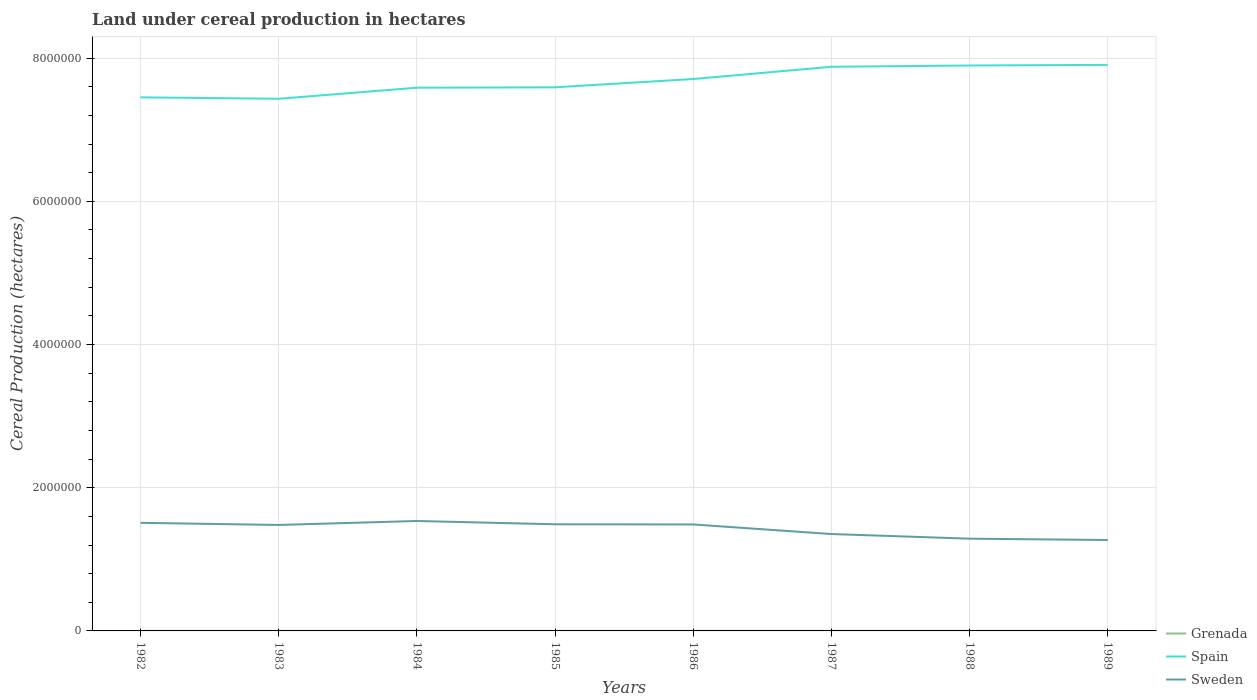Is the number of lines equal to the number of legend labels?
Ensure brevity in your answer.  Yes. Across all years, what is the maximum land under cereal production in Sweden?
Keep it short and to the point. 1.27e+06. What is the total land under cereal production in Sweden in the graph?
Make the answer very short. 8.33e+04. What is the difference between the highest and the second highest land under cereal production in Grenada?
Provide a short and direct response. 220. What is the difference between the highest and the lowest land under cereal production in Sweden?
Give a very brief answer. 5. Is the land under cereal production in Sweden strictly greater than the land under cereal production in Spain over the years?
Provide a succinct answer. Yes. How many lines are there?
Your response must be concise. 3. How many years are there in the graph?
Your answer should be very brief. 8. Are the values on the major ticks of Y-axis written in scientific E-notation?
Keep it short and to the point. No. Does the graph contain any zero values?
Your response must be concise. No. What is the title of the graph?
Offer a terse response. Land under cereal production in hectares. What is the label or title of the X-axis?
Provide a succinct answer. Years. What is the label or title of the Y-axis?
Offer a terse response. Cereal Production (hectares). What is the Cereal Production (hectares) of Grenada in 1982?
Provide a short and direct response. 470. What is the Cereal Production (hectares) of Spain in 1982?
Offer a very short reply. 7.45e+06. What is the Cereal Production (hectares) in Sweden in 1982?
Make the answer very short. 1.51e+06. What is the Cereal Production (hectares) in Grenada in 1983?
Provide a short and direct response. 414. What is the Cereal Production (hectares) in Spain in 1983?
Ensure brevity in your answer.  7.43e+06. What is the Cereal Production (hectares) of Sweden in 1983?
Make the answer very short. 1.48e+06. What is the Cereal Production (hectares) in Grenada in 1984?
Provide a succinct answer. 414. What is the Cereal Production (hectares) in Spain in 1984?
Provide a short and direct response. 7.59e+06. What is the Cereal Production (hectares) of Sweden in 1984?
Make the answer very short. 1.54e+06. What is the Cereal Production (hectares) in Grenada in 1985?
Your response must be concise. 410. What is the Cereal Production (hectares) in Spain in 1985?
Offer a very short reply. 7.59e+06. What is the Cereal Production (hectares) of Sweden in 1985?
Your answer should be very brief. 1.49e+06. What is the Cereal Production (hectares) in Grenada in 1986?
Provide a succinct answer. 250. What is the Cereal Production (hectares) in Spain in 1986?
Offer a terse response. 7.71e+06. What is the Cereal Production (hectares) in Sweden in 1986?
Offer a very short reply. 1.49e+06. What is the Cereal Production (hectares) in Grenada in 1987?
Your response must be concise. 250. What is the Cereal Production (hectares) of Spain in 1987?
Give a very brief answer. 7.88e+06. What is the Cereal Production (hectares) in Sweden in 1987?
Make the answer very short. 1.35e+06. What is the Cereal Production (hectares) of Grenada in 1988?
Offer a very short reply. 250. What is the Cereal Production (hectares) in Spain in 1988?
Make the answer very short. 7.90e+06. What is the Cereal Production (hectares) in Sweden in 1988?
Make the answer very short. 1.29e+06. What is the Cereal Production (hectares) of Grenada in 1989?
Your response must be concise. 255. What is the Cereal Production (hectares) in Spain in 1989?
Your response must be concise. 7.91e+06. What is the Cereal Production (hectares) of Sweden in 1989?
Your response must be concise. 1.27e+06. Across all years, what is the maximum Cereal Production (hectares) of Grenada?
Your answer should be compact. 470. Across all years, what is the maximum Cereal Production (hectares) in Spain?
Offer a very short reply. 7.91e+06. Across all years, what is the maximum Cereal Production (hectares) in Sweden?
Offer a terse response. 1.54e+06. Across all years, what is the minimum Cereal Production (hectares) of Grenada?
Your answer should be very brief. 250. Across all years, what is the minimum Cereal Production (hectares) in Spain?
Keep it short and to the point. 7.43e+06. Across all years, what is the minimum Cereal Production (hectares) of Sweden?
Ensure brevity in your answer.  1.27e+06. What is the total Cereal Production (hectares) in Grenada in the graph?
Offer a terse response. 2713. What is the total Cereal Production (hectares) of Spain in the graph?
Offer a terse response. 6.15e+07. What is the total Cereal Production (hectares) in Sweden in the graph?
Provide a succinct answer. 1.14e+07. What is the difference between the Cereal Production (hectares) in Spain in 1982 and that in 1983?
Offer a terse response. 1.99e+04. What is the difference between the Cereal Production (hectares) in Sweden in 1982 and that in 1983?
Provide a succinct answer. 2.98e+04. What is the difference between the Cereal Production (hectares) of Spain in 1982 and that in 1984?
Offer a terse response. -1.35e+05. What is the difference between the Cereal Production (hectares) in Sweden in 1982 and that in 1984?
Your response must be concise. -2.56e+04. What is the difference between the Cereal Production (hectares) of Spain in 1982 and that in 1985?
Give a very brief answer. -1.40e+05. What is the difference between the Cereal Production (hectares) in Sweden in 1982 and that in 1985?
Provide a short and direct response. 2.03e+04. What is the difference between the Cereal Production (hectares) in Grenada in 1982 and that in 1986?
Ensure brevity in your answer.  220. What is the difference between the Cereal Production (hectares) of Spain in 1982 and that in 1986?
Your response must be concise. -2.56e+05. What is the difference between the Cereal Production (hectares) of Sweden in 1982 and that in 1986?
Provide a succinct answer. 2.28e+04. What is the difference between the Cereal Production (hectares) in Grenada in 1982 and that in 1987?
Make the answer very short. 220. What is the difference between the Cereal Production (hectares) of Spain in 1982 and that in 1987?
Ensure brevity in your answer.  -4.27e+05. What is the difference between the Cereal Production (hectares) in Sweden in 1982 and that in 1987?
Provide a short and direct response. 1.57e+05. What is the difference between the Cereal Production (hectares) of Grenada in 1982 and that in 1988?
Provide a succinct answer. 220. What is the difference between the Cereal Production (hectares) of Spain in 1982 and that in 1988?
Ensure brevity in your answer.  -4.45e+05. What is the difference between the Cereal Production (hectares) in Sweden in 1982 and that in 1988?
Your answer should be very brief. 2.21e+05. What is the difference between the Cereal Production (hectares) in Grenada in 1982 and that in 1989?
Your answer should be very brief. 215. What is the difference between the Cereal Production (hectares) in Spain in 1982 and that in 1989?
Give a very brief answer. -4.53e+05. What is the difference between the Cereal Production (hectares) of Sweden in 1982 and that in 1989?
Offer a terse response. 2.40e+05. What is the difference between the Cereal Production (hectares) in Spain in 1983 and that in 1984?
Your answer should be very brief. -1.55e+05. What is the difference between the Cereal Production (hectares) in Sweden in 1983 and that in 1984?
Provide a succinct answer. -5.54e+04. What is the difference between the Cereal Production (hectares) of Spain in 1983 and that in 1985?
Offer a terse response. -1.60e+05. What is the difference between the Cereal Production (hectares) in Sweden in 1983 and that in 1985?
Ensure brevity in your answer.  -9501. What is the difference between the Cereal Production (hectares) of Grenada in 1983 and that in 1986?
Make the answer very short. 164. What is the difference between the Cereal Production (hectares) in Spain in 1983 and that in 1986?
Your answer should be very brief. -2.76e+05. What is the difference between the Cereal Production (hectares) of Sweden in 1983 and that in 1986?
Ensure brevity in your answer.  -7001. What is the difference between the Cereal Production (hectares) of Grenada in 1983 and that in 1987?
Give a very brief answer. 164. What is the difference between the Cereal Production (hectares) of Spain in 1983 and that in 1987?
Provide a succinct answer. -4.47e+05. What is the difference between the Cereal Production (hectares) in Sweden in 1983 and that in 1987?
Keep it short and to the point. 1.27e+05. What is the difference between the Cereal Production (hectares) in Grenada in 1983 and that in 1988?
Keep it short and to the point. 164. What is the difference between the Cereal Production (hectares) of Spain in 1983 and that in 1988?
Ensure brevity in your answer.  -4.65e+05. What is the difference between the Cereal Production (hectares) of Sweden in 1983 and that in 1988?
Ensure brevity in your answer.  1.92e+05. What is the difference between the Cereal Production (hectares) of Grenada in 1983 and that in 1989?
Keep it short and to the point. 159. What is the difference between the Cereal Production (hectares) of Spain in 1983 and that in 1989?
Offer a very short reply. -4.73e+05. What is the difference between the Cereal Production (hectares) in Sweden in 1983 and that in 1989?
Make the answer very short. 2.10e+05. What is the difference between the Cereal Production (hectares) of Grenada in 1984 and that in 1985?
Ensure brevity in your answer.  4. What is the difference between the Cereal Production (hectares) of Spain in 1984 and that in 1985?
Your response must be concise. -5503. What is the difference between the Cereal Production (hectares) in Sweden in 1984 and that in 1985?
Provide a succinct answer. 4.59e+04. What is the difference between the Cereal Production (hectares) in Grenada in 1984 and that in 1986?
Provide a succinct answer. 164. What is the difference between the Cereal Production (hectares) of Spain in 1984 and that in 1986?
Your response must be concise. -1.21e+05. What is the difference between the Cereal Production (hectares) in Sweden in 1984 and that in 1986?
Your answer should be very brief. 4.84e+04. What is the difference between the Cereal Production (hectares) in Grenada in 1984 and that in 1987?
Make the answer very short. 164. What is the difference between the Cereal Production (hectares) in Spain in 1984 and that in 1987?
Offer a terse response. -2.92e+05. What is the difference between the Cereal Production (hectares) of Sweden in 1984 and that in 1987?
Your answer should be very brief. 1.82e+05. What is the difference between the Cereal Production (hectares) of Grenada in 1984 and that in 1988?
Provide a succinct answer. 164. What is the difference between the Cereal Production (hectares) in Spain in 1984 and that in 1988?
Provide a short and direct response. -3.10e+05. What is the difference between the Cereal Production (hectares) in Sweden in 1984 and that in 1988?
Offer a very short reply. 2.47e+05. What is the difference between the Cereal Production (hectares) in Grenada in 1984 and that in 1989?
Keep it short and to the point. 159. What is the difference between the Cereal Production (hectares) in Spain in 1984 and that in 1989?
Ensure brevity in your answer.  -3.19e+05. What is the difference between the Cereal Production (hectares) of Sweden in 1984 and that in 1989?
Give a very brief answer. 2.65e+05. What is the difference between the Cereal Production (hectares) in Grenada in 1985 and that in 1986?
Keep it short and to the point. 160. What is the difference between the Cereal Production (hectares) of Spain in 1985 and that in 1986?
Your response must be concise. -1.16e+05. What is the difference between the Cereal Production (hectares) of Sweden in 1985 and that in 1986?
Offer a very short reply. 2500. What is the difference between the Cereal Production (hectares) in Grenada in 1985 and that in 1987?
Offer a very short reply. 160. What is the difference between the Cereal Production (hectares) in Spain in 1985 and that in 1987?
Your response must be concise. -2.87e+05. What is the difference between the Cereal Production (hectares) of Sweden in 1985 and that in 1987?
Your answer should be very brief. 1.36e+05. What is the difference between the Cereal Production (hectares) of Grenada in 1985 and that in 1988?
Keep it short and to the point. 160. What is the difference between the Cereal Production (hectares) of Spain in 1985 and that in 1988?
Ensure brevity in your answer.  -3.05e+05. What is the difference between the Cereal Production (hectares) in Sweden in 1985 and that in 1988?
Provide a short and direct response. 2.01e+05. What is the difference between the Cereal Production (hectares) in Grenada in 1985 and that in 1989?
Make the answer very short. 155. What is the difference between the Cereal Production (hectares) in Spain in 1985 and that in 1989?
Make the answer very short. -3.13e+05. What is the difference between the Cereal Production (hectares) in Sweden in 1985 and that in 1989?
Offer a terse response. 2.20e+05. What is the difference between the Cereal Production (hectares) in Grenada in 1986 and that in 1987?
Give a very brief answer. 0. What is the difference between the Cereal Production (hectares) of Spain in 1986 and that in 1987?
Your response must be concise. -1.71e+05. What is the difference between the Cereal Production (hectares) of Sweden in 1986 and that in 1987?
Ensure brevity in your answer.  1.34e+05. What is the difference between the Cereal Production (hectares) in Grenada in 1986 and that in 1988?
Offer a terse response. 0. What is the difference between the Cereal Production (hectares) in Spain in 1986 and that in 1988?
Keep it short and to the point. -1.89e+05. What is the difference between the Cereal Production (hectares) of Sweden in 1986 and that in 1988?
Provide a succinct answer. 1.99e+05. What is the difference between the Cereal Production (hectares) of Spain in 1986 and that in 1989?
Your answer should be compact. -1.98e+05. What is the difference between the Cereal Production (hectares) in Sweden in 1986 and that in 1989?
Give a very brief answer. 2.17e+05. What is the difference between the Cereal Production (hectares) in Spain in 1987 and that in 1988?
Make the answer very short. -1.81e+04. What is the difference between the Cereal Production (hectares) of Sweden in 1987 and that in 1988?
Keep it short and to the point. 6.49e+04. What is the difference between the Cereal Production (hectares) in Spain in 1987 and that in 1989?
Make the answer very short. -2.66e+04. What is the difference between the Cereal Production (hectares) of Sweden in 1987 and that in 1989?
Provide a succinct answer. 8.33e+04. What is the difference between the Cereal Production (hectares) in Spain in 1988 and that in 1989?
Offer a terse response. -8497. What is the difference between the Cereal Production (hectares) in Sweden in 1988 and that in 1989?
Make the answer very short. 1.85e+04. What is the difference between the Cereal Production (hectares) of Grenada in 1982 and the Cereal Production (hectares) of Spain in 1983?
Your answer should be compact. -7.43e+06. What is the difference between the Cereal Production (hectares) of Grenada in 1982 and the Cereal Production (hectares) of Sweden in 1983?
Provide a succinct answer. -1.48e+06. What is the difference between the Cereal Production (hectares) of Spain in 1982 and the Cereal Production (hectares) of Sweden in 1983?
Your answer should be very brief. 5.97e+06. What is the difference between the Cereal Production (hectares) in Grenada in 1982 and the Cereal Production (hectares) in Spain in 1984?
Make the answer very short. -7.59e+06. What is the difference between the Cereal Production (hectares) in Grenada in 1982 and the Cereal Production (hectares) in Sweden in 1984?
Make the answer very short. -1.53e+06. What is the difference between the Cereal Production (hectares) in Spain in 1982 and the Cereal Production (hectares) in Sweden in 1984?
Your answer should be very brief. 5.92e+06. What is the difference between the Cereal Production (hectares) of Grenada in 1982 and the Cereal Production (hectares) of Spain in 1985?
Your answer should be compact. -7.59e+06. What is the difference between the Cereal Production (hectares) of Grenada in 1982 and the Cereal Production (hectares) of Sweden in 1985?
Provide a succinct answer. -1.49e+06. What is the difference between the Cereal Production (hectares) in Spain in 1982 and the Cereal Production (hectares) in Sweden in 1985?
Provide a succinct answer. 5.96e+06. What is the difference between the Cereal Production (hectares) in Grenada in 1982 and the Cereal Production (hectares) in Spain in 1986?
Your answer should be very brief. -7.71e+06. What is the difference between the Cereal Production (hectares) of Grenada in 1982 and the Cereal Production (hectares) of Sweden in 1986?
Your answer should be very brief. -1.49e+06. What is the difference between the Cereal Production (hectares) in Spain in 1982 and the Cereal Production (hectares) in Sweden in 1986?
Provide a succinct answer. 5.97e+06. What is the difference between the Cereal Production (hectares) in Grenada in 1982 and the Cereal Production (hectares) in Spain in 1987?
Keep it short and to the point. -7.88e+06. What is the difference between the Cereal Production (hectares) in Grenada in 1982 and the Cereal Production (hectares) in Sweden in 1987?
Offer a terse response. -1.35e+06. What is the difference between the Cereal Production (hectares) of Spain in 1982 and the Cereal Production (hectares) of Sweden in 1987?
Offer a terse response. 6.10e+06. What is the difference between the Cereal Production (hectares) in Grenada in 1982 and the Cereal Production (hectares) in Spain in 1988?
Ensure brevity in your answer.  -7.90e+06. What is the difference between the Cereal Production (hectares) in Grenada in 1982 and the Cereal Production (hectares) in Sweden in 1988?
Your answer should be compact. -1.29e+06. What is the difference between the Cereal Production (hectares) of Spain in 1982 and the Cereal Production (hectares) of Sweden in 1988?
Your answer should be very brief. 6.16e+06. What is the difference between the Cereal Production (hectares) of Grenada in 1982 and the Cereal Production (hectares) of Spain in 1989?
Offer a very short reply. -7.91e+06. What is the difference between the Cereal Production (hectares) in Grenada in 1982 and the Cereal Production (hectares) in Sweden in 1989?
Provide a short and direct response. -1.27e+06. What is the difference between the Cereal Production (hectares) of Spain in 1982 and the Cereal Production (hectares) of Sweden in 1989?
Ensure brevity in your answer.  6.18e+06. What is the difference between the Cereal Production (hectares) of Grenada in 1983 and the Cereal Production (hectares) of Spain in 1984?
Make the answer very short. -7.59e+06. What is the difference between the Cereal Production (hectares) in Grenada in 1983 and the Cereal Production (hectares) in Sweden in 1984?
Your response must be concise. -1.53e+06. What is the difference between the Cereal Production (hectares) of Spain in 1983 and the Cereal Production (hectares) of Sweden in 1984?
Keep it short and to the point. 5.90e+06. What is the difference between the Cereal Production (hectares) of Grenada in 1983 and the Cereal Production (hectares) of Spain in 1985?
Your response must be concise. -7.59e+06. What is the difference between the Cereal Production (hectares) in Grenada in 1983 and the Cereal Production (hectares) in Sweden in 1985?
Offer a very short reply. -1.49e+06. What is the difference between the Cereal Production (hectares) in Spain in 1983 and the Cereal Production (hectares) in Sweden in 1985?
Offer a very short reply. 5.94e+06. What is the difference between the Cereal Production (hectares) of Grenada in 1983 and the Cereal Production (hectares) of Spain in 1986?
Give a very brief answer. -7.71e+06. What is the difference between the Cereal Production (hectares) in Grenada in 1983 and the Cereal Production (hectares) in Sweden in 1986?
Ensure brevity in your answer.  -1.49e+06. What is the difference between the Cereal Production (hectares) in Spain in 1983 and the Cereal Production (hectares) in Sweden in 1986?
Keep it short and to the point. 5.95e+06. What is the difference between the Cereal Production (hectares) of Grenada in 1983 and the Cereal Production (hectares) of Spain in 1987?
Ensure brevity in your answer.  -7.88e+06. What is the difference between the Cereal Production (hectares) in Grenada in 1983 and the Cereal Production (hectares) in Sweden in 1987?
Your response must be concise. -1.35e+06. What is the difference between the Cereal Production (hectares) of Spain in 1983 and the Cereal Production (hectares) of Sweden in 1987?
Ensure brevity in your answer.  6.08e+06. What is the difference between the Cereal Production (hectares) of Grenada in 1983 and the Cereal Production (hectares) of Spain in 1988?
Offer a very short reply. -7.90e+06. What is the difference between the Cereal Production (hectares) in Grenada in 1983 and the Cereal Production (hectares) in Sweden in 1988?
Offer a terse response. -1.29e+06. What is the difference between the Cereal Production (hectares) of Spain in 1983 and the Cereal Production (hectares) of Sweden in 1988?
Provide a succinct answer. 6.14e+06. What is the difference between the Cereal Production (hectares) of Grenada in 1983 and the Cereal Production (hectares) of Spain in 1989?
Provide a short and direct response. -7.91e+06. What is the difference between the Cereal Production (hectares) in Grenada in 1983 and the Cereal Production (hectares) in Sweden in 1989?
Your answer should be very brief. -1.27e+06. What is the difference between the Cereal Production (hectares) of Spain in 1983 and the Cereal Production (hectares) of Sweden in 1989?
Offer a very short reply. 6.16e+06. What is the difference between the Cereal Production (hectares) in Grenada in 1984 and the Cereal Production (hectares) in Spain in 1985?
Your answer should be very brief. -7.59e+06. What is the difference between the Cereal Production (hectares) in Grenada in 1984 and the Cereal Production (hectares) in Sweden in 1985?
Give a very brief answer. -1.49e+06. What is the difference between the Cereal Production (hectares) of Spain in 1984 and the Cereal Production (hectares) of Sweden in 1985?
Make the answer very short. 6.10e+06. What is the difference between the Cereal Production (hectares) in Grenada in 1984 and the Cereal Production (hectares) in Spain in 1986?
Your answer should be compact. -7.71e+06. What is the difference between the Cereal Production (hectares) of Grenada in 1984 and the Cereal Production (hectares) of Sweden in 1986?
Your response must be concise. -1.49e+06. What is the difference between the Cereal Production (hectares) in Spain in 1984 and the Cereal Production (hectares) in Sweden in 1986?
Ensure brevity in your answer.  6.10e+06. What is the difference between the Cereal Production (hectares) in Grenada in 1984 and the Cereal Production (hectares) in Spain in 1987?
Provide a succinct answer. -7.88e+06. What is the difference between the Cereal Production (hectares) in Grenada in 1984 and the Cereal Production (hectares) in Sweden in 1987?
Ensure brevity in your answer.  -1.35e+06. What is the difference between the Cereal Production (hectares) of Spain in 1984 and the Cereal Production (hectares) of Sweden in 1987?
Provide a succinct answer. 6.23e+06. What is the difference between the Cereal Production (hectares) of Grenada in 1984 and the Cereal Production (hectares) of Spain in 1988?
Provide a succinct answer. -7.90e+06. What is the difference between the Cereal Production (hectares) of Grenada in 1984 and the Cereal Production (hectares) of Sweden in 1988?
Provide a short and direct response. -1.29e+06. What is the difference between the Cereal Production (hectares) in Spain in 1984 and the Cereal Production (hectares) in Sweden in 1988?
Your answer should be very brief. 6.30e+06. What is the difference between the Cereal Production (hectares) in Grenada in 1984 and the Cereal Production (hectares) in Spain in 1989?
Offer a terse response. -7.91e+06. What is the difference between the Cereal Production (hectares) of Grenada in 1984 and the Cereal Production (hectares) of Sweden in 1989?
Make the answer very short. -1.27e+06. What is the difference between the Cereal Production (hectares) in Spain in 1984 and the Cereal Production (hectares) in Sweden in 1989?
Offer a very short reply. 6.32e+06. What is the difference between the Cereal Production (hectares) of Grenada in 1985 and the Cereal Production (hectares) of Spain in 1986?
Offer a terse response. -7.71e+06. What is the difference between the Cereal Production (hectares) in Grenada in 1985 and the Cereal Production (hectares) in Sweden in 1986?
Offer a very short reply. -1.49e+06. What is the difference between the Cereal Production (hectares) of Spain in 1985 and the Cereal Production (hectares) of Sweden in 1986?
Offer a terse response. 6.11e+06. What is the difference between the Cereal Production (hectares) in Grenada in 1985 and the Cereal Production (hectares) in Spain in 1987?
Keep it short and to the point. -7.88e+06. What is the difference between the Cereal Production (hectares) of Grenada in 1985 and the Cereal Production (hectares) of Sweden in 1987?
Make the answer very short. -1.35e+06. What is the difference between the Cereal Production (hectares) in Spain in 1985 and the Cereal Production (hectares) in Sweden in 1987?
Provide a succinct answer. 6.24e+06. What is the difference between the Cereal Production (hectares) in Grenada in 1985 and the Cereal Production (hectares) in Spain in 1988?
Your answer should be very brief. -7.90e+06. What is the difference between the Cereal Production (hectares) in Grenada in 1985 and the Cereal Production (hectares) in Sweden in 1988?
Offer a very short reply. -1.29e+06. What is the difference between the Cereal Production (hectares) in Spain in 1985 and the Cereal Production (hectares) in Sweden in 1988?
Keep it short and to the point. 6.30e+06. What is the difference between the Cereal Production (hectares) in Grenada in 1985 and the Cereal Production (hectares) in Spain in 1989?
Offer a very short reply. -7.91e+06. What is the difference between the Cereal Production (hectares) in Grenada in 1985 and the Cereal Production (hectares) in Sweden in 1989?
Offer a terse response. -1.27e+06. What is the difference between the Cereal Production (hectares) of Spain in 1985 and the Cereal Production (hectares) of Sweden in 1989?
Keep it short and to the point. 6.32e+06. What is the difference between the Cereal Production (hectares) in Grenada in 1986 and the Cereal Production (hectares) in Spain in 1987?
Give a very brief answer. -7.88e+06. What is the difference between the Cereal Production (hectares) in Grenada in 1986 and the Cereal Production (hectares) in Sweden in 1987?
Keep it short and to the point. -1.35e+06. What is the difference between the Cereal Production (hectares) in Spain in 1986 and the Cereal Production (hectares) in Sweden in 1987?
Provide a succinct answer. 6.36e+06. What is the difference between the Cereal Production (hectares) in Grenada in 1986 and the Cereal Production (hectares) in Spain in 1988?
Provide a succinct answer. -7.90e+06. What is the difference between the Cereal Production (hectares) in Grenada in 1986 and the Cereal Production (hectares) in Sweden in 1988?
Your answer should be compact. -1.29e+06. What is the difference between the Cereal Production (hectares) in Spain in 1986 and the Cereal Production (hectares) in Sweden in 1988?
Make the answer very short. 6.42e+06. What is the difference between the Cereal Production (hectares) of Grenada in 1986 and the Cereal Production (hectares) of Spain in 1989?
Provide a short and direct response. -7.91e+06. What is the difference between the Cereal Production (hectares) in Grenada in 1986 and the Cereal Production (hectares) in Sweden in 1989?
Give a very brief answer. -1.27e+06. What is the difference between the Cereal Production (hectares) in Spain in 1986 and the Cereal Production (hectares) in Sweden in 1989?
Offer a terse response. 6.44e+06. What is the difference between the Cereal Production (hectares) in Grenada in 1987 and the Cereal Production (hectares) in Spain in 1988?
Ensure brevity in your answer.  -7.90e+06. What is the difference between the Cereal Production (hectares) in Grenada in 1987 and the Cereal Production (hectares) in Sweden in 1988?
Provide a succinct answer. -1.29e+06. What is the difference between the Cereal Production (hectares) of Spain in 1987 and the Cereal Production (hectares) of Sweden in 1988?
Offer a terse response. 6.59e+06. What is the difference between the Cereal Production (hectares) of Grenada in 1987 and the Cereal Production (hectares) of Spain in 1989?
Provide a short and direct response. -7.91e+06. What is the difference between the Cereal Production (hectares) in Grenada in 1987 and the Cereal Production (hectares) in Sweden in 1989?
Your response must be concise. -1.27e+06. What is the difference between the Cereal Production (hectares) in Spain in 1987 and the Cereal Production (hectares) in Sweden in 1989?
Provide a succinct answer. 6.61e+06. What is the difference between the Cereal Production (hectares) of Grenada in 1988 and the Cereal Production (hectares) of Spain in 1989?
Your answer should be very brief. -7.91e+06. What is the difference between the Cereal Production (hectares) in Grenada in 1988 and the Cereal Production (hectares) in Sweden in 1989?
Your answer should be very brief. -1.27e+06. What is the difference between the Cereal Production (hectares) of Spain in 1988 and the Cereal Production (hectares) of Sweden in 1989?
Keep it short and to the point. 6.63e+06. What is the average Cereal Production (hectares) of Grenada per year?
Provide a short and direct response. 339.12. What is the average Cereal Production (hectares) of Spain per year?
Give a very brief answer. 7.68e+06. What is the average Cereal Production (hectares) of Sweden per year?
Keep it short and to the point. 1.43e+06. In the year 1982, what is the difference between the Cereal Production (hectares) in Grenada and Cereal Production (hectares) in Spain?
Offer a very short reply. -7.45e+06. In the year 1982, what is the difference between the Cereal Production (hectares) of Grenada and Cereal Production (hectares) of Sweden?
Offer a very short reply. -1.51e+06. In the year 1982, what is the difference between the Cereal Production (hectares) of Spain and Cereal Production (hectares) of Sweden?
Your answer should be very brief. 5.94e+06. In the year 1983, what is the difference between the Cereal Production (hectares) in Grenada and Cereal Production (hectares) in Spain?
Your response must be concise. -7.43e+06. In the year 1983, what is the difference between the Cereal Production (hectares) in Grenada and Cereal Production (hectares) in Sweden?
Your response must be concise. -1.48e+06. In the year 1983, what is the difference between the Cereal Production (hectares) in Spain and Cereal Production (hectares) in Sweden?
Make the answer very short. 5.95e+06. In the year 1984, what is the difference between the Cereal Production (hectares) of Grenada and Cereal Production (hectares) of Spain?
Offer a very short reply. -7.59e+06. In the year 1984, what is the difference between the Cereal Production (hectares) of Grenada and Cereal Production (hectares) of Sweden?
Your response must be concise. -1.53e+06. In the year 1984, what is the difference between the Cereal Production (hectares) of Spain and Cereal Production (hectares) of Sweden?
Ensure brevity in your answer.  6.05e+06. In the year 1985, what is the difference between the Cereal Production (hectares) of Grenada and Cereal Production (hectares) of Spain?
Provide a succinct answer. -7.59e+06. In the year 1985, what is the difference between the Cereal Production (hectares) in Grenada and Cereal Production (hectares) in Sweden?
Offer a terse response. -1.49e+06. In the year 1985, what is the difference between the Cereal Production (hectares) of Spain and Cereal Production (hectares) of Sweden?
Offer a terse response. 6.10e+06. In the year 1986, what is the difference between the Cereal Production (hectares) of Grenada and Cereal Production (hectares) of Spain?
Offer a very short reply. -7.71e+06. In the year 1986, what is the difference between the Cereal Production (hectares) in Grenada and Cereal Production (hectares) in Sweden?
Your answer should be compact. -1.49e+06. In the year 1986, what is the difference between the Cereal Production (hectares) of Spain and Cereal Production (hectares) of Sweden?
Keep it short and to the point. 6.22e+06. In the year 1987, what is the difference between the Cereal Production (hectares) in Grenada and Cereal Production (hectares) in Spain?
Offer a very short reply. -7.88e+06. In the year 1987, what is the difference between the Cereal Production (hectares) of Grenada and Cereal Production (hectares) of Sweden?
Provide a succinct answer. -1.35e+06. In the year 1987, what is the difference between the Cereal Production (hectares) in Spain and Cereal Production (hectares) in Sweden?
Make the answer very short. 6.53e+06. In the year 1988, what is the difference between the Cereal Production (hectares) of Grenada and Cereal Production (hectares) of Spain?
Ensure brevity in your answer.  -7.90e+06. In the year 1988, what is the difference between the Cereal Production (hectares) in Grenada and Cereal Production (hectares) in Sweden?
Offer a terse response. -1.29e+06. In the year 1988, what is the difference between the Cereal Production (hectares) in Spain and Cereal Production (hectares) in Sweden?
Give a very brief answer. 6.61e+06. In the year 1989, what is the difference between the Cereal Production (hectares) of Grenada and Cereal Production (hectares) of Spain?
Your response must be concise. -7.91e+06. In the year 1989, what is the difference between the Cereal Production (hectares) of Grenada and Cereal Production (hectares) of Sweden?
Ensure brevity in your answer.  -1.27e+06. In the year 1989, what is the difference between the Cereal Production (hectares) in Spain and Cereal Production (hectares) in Sweden?
Provide a succinct answer. 6.64e+06. What is the ratio of the Cereal Production (hectares) in Grenada in 1982 to that in 1983?
Provide a succinct answer. 1.14. What is the ratio of the Cereal Production (hectares) in Sweden in 1982 to that in 1983?
Your answer should be very brief. 1.02. What is the ratio of the Cereal Production (hectares) of Grenada in 1982 to that in 1984?
Your response must be concise. 1.14. What is the ratio of the Cereal Production (hectares) in Spain in 1982 to that in 1984?
Provide a short and direct response. 0.98. What is the ratio of the Cereal Production (hectares) in Sweden in 1982 to that in 1984?
Your answer should be very brief. 0.98. What is the ratio of the Cereal Production (hectares) of Grenada in 1982 to that in 1985?
Provide a short and direct response. 1.15. What is the ratio of the Cereal Production (hectares) in Spain in 1982 to that in 1985?
Your answer should be very brief. 0.98. What is the ratio of the Cereal Production (hectares) of Sweden in 1982 to that in 1985?
Ensure brevity in your answer.  1.01. What is the ratio of the Cereal Production (hectares) of Grenada in 1982 to that in 1986?
Provide a short and direct response. 1.88. What is the ratio of the Cereal Production (hectares) of Spain in 1982 to that in 1986?
Provide a succinct answer. 0.97. What is the ratio of the Cereal Production (hectares) of Sweden in 1982 to that in 1986?
Provide a short and direct response. 1.02. What is the ratio of the Cereal Production (hectares) in Grenada in 1982 to that in 1987?
Offer a very short reply. 1.88. What is the ratio of the Cereal Production (hectares) of Spain in 1982 to that in 1987?
Provide a short and direct response. 0.95. What is the ratio of the Cereal Production (hectares) in Sweden in 1982 to that in 1987?
Your answer should be compact. 1.12. What is the ratio of the Cereal Production (hectares) in Grenada in 1982 to that in 1988?
Offer a very short reply. 1.88. What is the ratio of the Cereal Production (hectares) of Spain in 1982 to that in 1988?
Your answer should be compact. 0.94. What is the ratio of the Cereal Production (hectares) of Sweden in 1982 to that in 1988?
Keep it short and to the point. 1.17. What is the ratio of the Cereal Production (hectares) in Grenada in 1982 to that in 1989?
Provide a short and direct response. 1.84. What is the ratio of the Cereal Production (hectares) in Spain in 1982 to that in 1989?
Provide a short and direct response. 0.94. What is the ratio of the Cereal Production (hectares) in Sweden in 1982 to that in 1989?
Provide a short and direct response. 1.19. What is the ratio of the Cereal Production (hectares) of Spain in 1983 to that in 1984?
Give a very brief answer. 0.98. What is the ratio of the Cereal Production (hectares) of Sweden in 1983 to that in 1984?
Provide a short and direct response. 0.96. What is the ratio of the Cereal Production (hectares) in Grenada in 1983 to that in 1985?
Your answer should be compact. 1.01. What is the ratio of the Cereal Production (hectares) in Spain in 1983 to that in 1985?
Ensure brevity in your answer.  0.98. What is the ratio of the Cereal Production (hectares) of Sweden in 1983 to that in 1985?
Offer a terse response. 0.99. What is the ratio of the Cereal Production (hectares) of Grenada in 1983 to that in 1986?
Keep it short and to the point. 1.66. What is the ratio of the Cereal Production (hectares) of Spain in 1983 to that in 1986?
Your answer should be compact. 0.96. What is the ratio of the Cereal Production (hectares) in Sweden in 1983 to that in 1986?
Keep it short and to the point. 1. What is the ratio of the Cereal Production (hectares) in Grenada in 1983 to that in 1987?
Provide a short and direct response. 1.66. What is the ratio of the Cereal Production (hectares) in Spain in 1983 to that in 1987?
Provide a short and direct response. 0.94. What is the ratio of the Cereal Production (hectares) of Sweden in 1983 to that in 1987?
Provide a succinct answer. 1.09. What is the ratio of the Cereal Production (hectares) of Grenada in 1983 to that in 1988?
Make the answer very short. 1.66. What is the ratio of the Cereal Production (hectares) in Spain in 1983 to that in 1988?
Your answer should be compact. 0.94. What is the ratio of the Cereal Production (hectares) of Sweden in 1983 to that in 1988?
Ensure brevity in your answer.  1.15. What is the ratio of the Cereal Production (hectares) in Grenada in 1983 to that in 1989?
Give a very brief answer. 1.62. What is the ratio of the Cereal Production (hectares) in Spain in 1983 to that in 1989?
Your answer should be compact. 0.94. What is the ratio of the Cereal Production (hectares) in Sweden in 1983 to that in 1989?
Offer a very short reply. 1.17. What is the ratio of the Cereal Production (hectares) of Grenada in 1984 to that in 1985?
Your answer should be compact. 1.01. What is the ratio of the Cereal Production (hectares) of Spain in 1984 to that in 1985?
Offer a terse response. 1. What is the ratio of the Cereal Production (hectares) of Sweden in 1984 to that in 1985?
Give a very brief answer. 1.03. What is the ratio of the Cereal Production (hectares) of Grenada in 1984 to that in 1986?
Your answer should be very brief. 1.66. What is the ratio of the Cereal Production (hectares) in Spain in 1984 to that in 1986?
Provide a succinct answer. 0.98. What is the ratio of the Cereal Production (hectares) in Sweden in 1984 to that in 1986?
Keep it short and to the point. 1.03. What is the ratio of the Cereal Production (hectares) of Grenada in 1984 to that in 1987?
Your answer should be very brief. 1.66. What is the ratio of the Cereal Production (hectares) in Spain in 1984 to that in 1987?
Ensure brevity in your answer.  0.96. What is the ratio of the Cereal Production (hectares) of Sweden in 1984 to that in 1987?
Your answer should be very brief. 1.13. What is the ratio of the Cereal Production (hectares) of Grenada in 1984 to that in 1988?
Your response must be concise. 1.66. What is the ratio of the Cereal Production (hectares) of Spain in 1984 to that in 1988?
Offer a very short reply. 0.96. What is the ratio of the Cereal Production (hectares) of Sweden in 1984 to that in 1988?
Provide a succinct answer. 1.19. What is the ratio of the Cereal Production (hectares) in Grenada in 1984 to that in 1989?
Ensure brevity in your answer.  1.62. What is the ratio of the Cereal Production (hectares) in Spain in 1984 to that in 1989?
Provide a short and direct response. 0.96. What is the ratio of the Cereal Production (hectares) in Sweden in 1984 to that in 1989?
Provide a succinct answer. 1.21. What is the ratio of the Cereal Production (hectares) of Grenada in 1985 to that in 1986?
Keep it short and to the point. 1.64. What is the ratio of the Cereal Production (hectares) of Spain in 1985 to that in 1986?
Provide a succinct answer. 0.98. What is the ratio of the Cereal Production (hectares) of Sweden in 1985 to that in 1986?
Offer a terse response. 1. What is the ratio of the Cereal Production (hectares) in Grenada in 1985 to that in 1987?
Provide a short and direct response. 1.64. What is the ratio of the Cereal Production (hectares) in Spain in 1985 to that in 1987?
Offer a very short reply. 0.96. What is the ratio of the Cereal Production (hectares) in Sweden in 1985 to that in 1987?
Make the answer very short. 1.1. What is the ratio of the Cereal Production (hectares) in Grenada in 1985 to that in 1988?
Provide a short and direct response. 1.64. What is the ratio of the Cereal Production (hectares) of Spain in 1985 to that in 1988?
Provide a short and direct response. 0.96. What is the ratio of the Cereal Production (hectares) of Sweden in 1985 to that in 1988?
Your answer should be compact. 1.16. What is the ratio of the Cereal Production (hectares) of Grenada in 1985 to that in 1989?
Your answer should be very brief. 1.61. What is the ratio of the Cereal Production (hectares) in Spain in 1985 to that in 1989?
Your answer should be compact. 0.96. What is the ratio of the Cereal Production (hectares) in Sweden in 1985 to that in 1989?
Make the answer very short. 1.17. What is the ratio of the Cereal Production (hectares) in Spain in 1986 to that in 1987?
Your answer should be very brief. 0.98. What is the ratio of the Cereal Production (hectares) in Sweden in 1986 to that in 1987?
Your response must be concise. 1.1. What is the ratio of the Cereal Production (hectares) of Spain in 1986 to that in 1988?
Your response must be concise. 0.98. What is the ratio of the Cereal Production (hectares) of Sweden in 1986 to that in 1988?
Offer a very short reply. 1.15. What is the ratio of the Cereal Production (hectares) of Grenada in 1986 to that in 1989?
Provide a short and direct response. 0.98. What is the ratio of the Cereal Production (hectares) of Sweden in 1986 to that in 1989?
Provide a succinct answer. 1.17. What is the ratio of the Cereal Production (hectares) of Spain in 1987 to that in 1988?
Provide a short and direct response. 1. What is the ratio of the Cereal Production (hectares) in Sweden in 1987 to that in 1988?
Your answer should be compact. 1.05. What is the ratio of the Cereal Production (hectares) in Grenada in 1987 to that in 1989?
Provide a succinct answer. 0.98. What is the ratio of the Cereal Production (hectares) of Sweden in 1987 to that in 1989?
Your answer should be very brief. 1.07. What is the ratio of the Cereal Production (hectares) of Grenada in 1988 to that in 1989?
Your answer should be compact. 0.98. What is the ratio of the Cereal Production (hectares) in Spain in 1988 to that in 1989?
Offer a terse response. 1. What is the ratio of the Cereal Production (hectares) in Sweden in 1988 to that in 1989?
Your answer should be very brief. 1.01. What is the difference between the highest and the second highest Cereal Production (hectares) in Spain?
Your answer should be compact. 8497. What is the difference between the highest and the second highest Cereal Production (hectares) in Sweden?
Give a very brief answer. 2.56e+04. What is the difference between the highest and the lowest Cereal Production (hectares) in Grenada?
Your answer should be compact. 220. What is the difference between the highest and the lowest Cereal Production (hectares) in Spain?
Ensure brevity in your answer.  4.73e+05. What is the difference between the highest and the lowest Cereal Production (hectares) of Sweden?
Ensure brevity in your answer.  2.65e+05. 